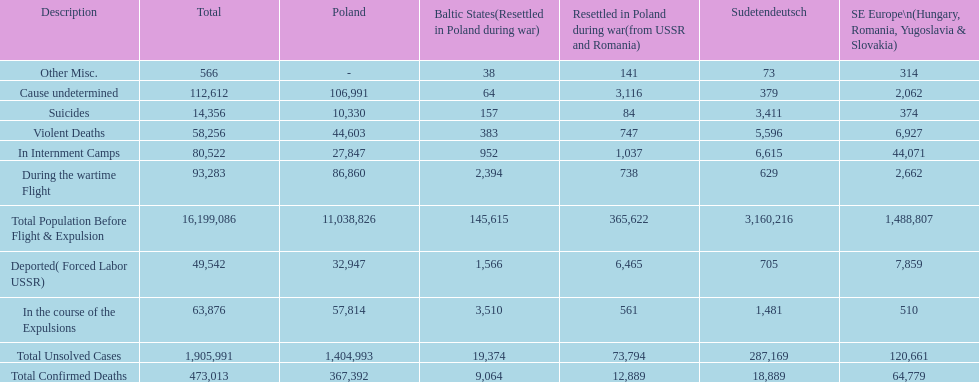Were there more cause undetermined or miscellaneous deaths in the baltic states? Cause undetermined. 